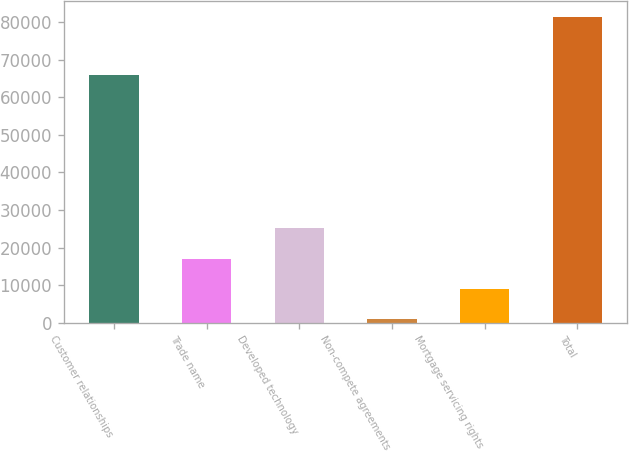Convert chart to OTSL. <chart><loc_0><loc_0><loc_500><loc_500><bar_chart><fcel>Customer relationships<fcel>Trade name<fcel>Developed technology<fcel>Non-compete agreements<fcel>Mortgage servicing rights<fcel>Total<nl><fcel>65957<fcel>17090<fcel>25135<fcel>1000<fcel>9045<fcel>81450<nl></chart> 